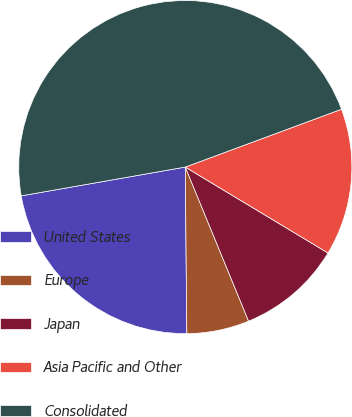Convert chart to OTSL. <chart><loc_0><loc_0><loc_500><loc_500><pie_chart><fcel>United States<fcel>Europe<fcel>Japan<fcel>Asia Pacific and Other<fcel>Consolidated<nl><fcel>22.38%<fcel>6.06%<fcel>10.17%<fcel>14.27%<fcel>47.12%<nl></chart> 